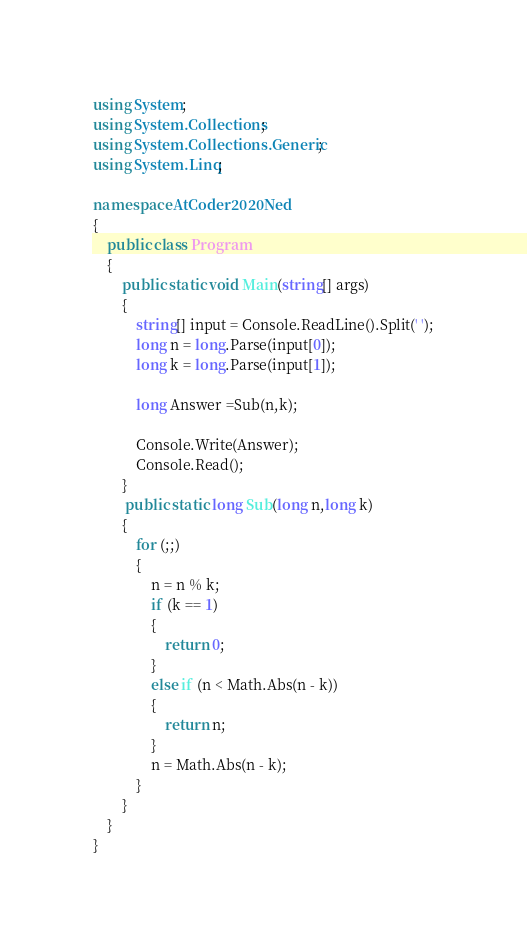Convert code to text. <code><loc_0><loc_0><loc_500><loc_500><_C#_>using System;
using System.Collections;
using System.Collections.Generic;
using System.Linq;

namespace AtCoder2020Ned
{
    public class Program
    {
        public static void Main(string[] args)
        {
            string[] input = Console.ReadLine().Split(' ');
            long n = long.Parse(input[0]);
            long k = long.Parse(input[1]);

            long Answer =Sub(n,k);
            
            Console.Write(Answer);
            Console.Read();
        }
         public static long Sub(long n,long k)
        {
            for (;;)
            {
                n = n % k;
                if (k == 1)
                {
                    return 0;
                }
                else if (n < Math.Abs(n - k))
                {
                    return n;                    
                }
                n = Math.Abs(n - k);
            }
        }
    }
}
</code> 